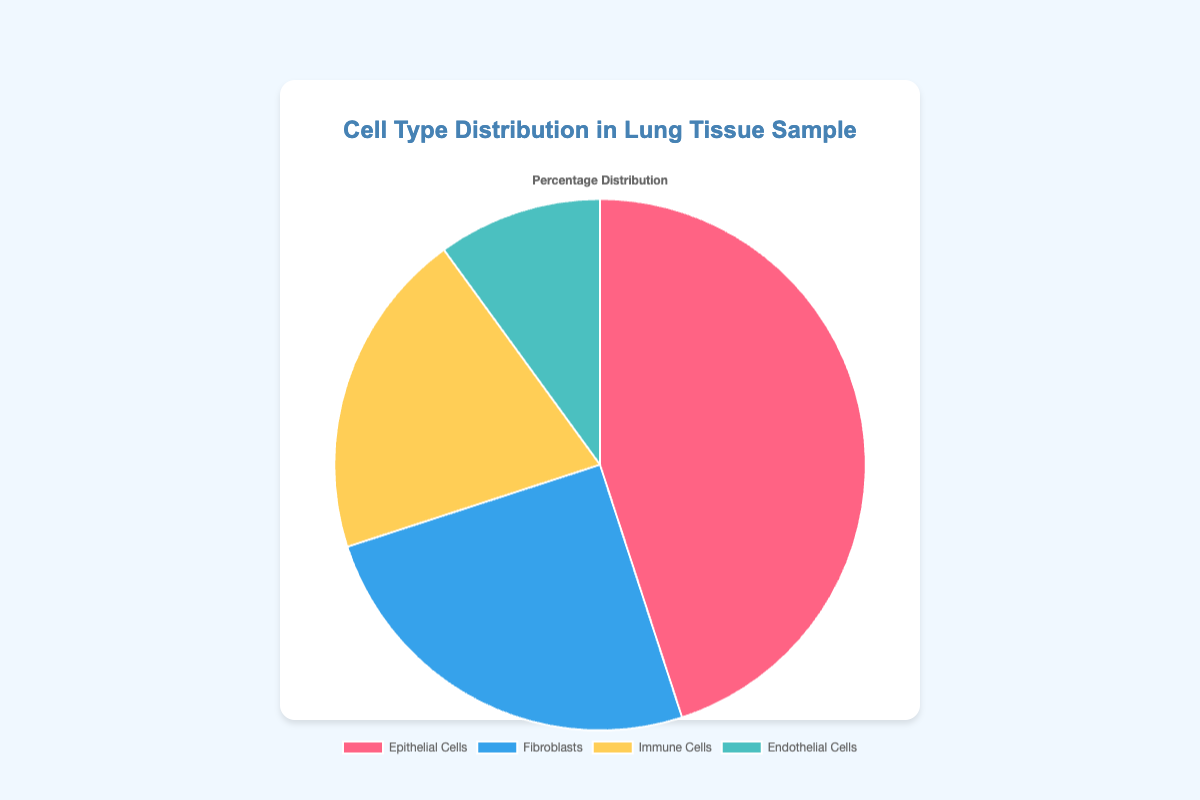What's the most abundant cell type in the lung tissue sample? The largest section of the pie chart represents the cell type with the highest percentage. Here, the section for Epithelial Cells is the largest.
Answer: Epithelial Cells What's the least abundant cell type in the lung tissue sample? The smallest section of the pie chart represents the cell type with the lowest percentage. Here, the section for Endothelial Cells is the smallest.
Answer: Endothelial Cells What is the combined percentage of Immune Cells and Fibroblasts? To find the combined percentage, add the percentages of Immune Cells (20%) and Fibroblasts (25%). 20 + 25 = 45
Answer: 45% How much larger is the percentage of Epithelial Cells compared to Endothelial Cells? Subtract the percentage of Endothelial Cells (10%) from the percentage of Epithelial Cells (45%). 45 - 10 = 35
Answer: 35% What percentage of the lung tissue sample is made up of cells that are not Immune Cells? Subtract the percentage of Immune Cells (20%) from the total (100%). 100 - 20 = 80
Answer: 80% Which cell type has a percentage that is closest to 25%? Compare the percentages of all cell types. The percentage closest to 25% is for Fibroblasts, which is exactly 25%.
Answer: Fibroblasts Are Epithelial Cells more than twice as abundant as Endothelial Cells? Compare twice the percentage of Endothelial Cells (2 * 10% = 20%) to the percentage of Epithelial Cells (45%). Since 45% is more than 20%, Epithelial Cells are more than twice as abundant as Endothelial Cells.
Answer: Yes If you were to merge Fibroblasts and Endothelial Cells into one group, what would the new group's percentage be? Add the percentages of Fibroblasts (25%) and Endothelial Cells (10%). 25 + 10 = 35
Answer: 35% Which two cell types together make up exactly 55% of the lung tissue sample? By adding different combinations of percentages, we find that Epithelial Cells (45%) + Endothelial Cells (10%) = 55%.
Answer: Epithelial Cells and Endothelial Cells How many cell types have a percentage greater than 20%? Identify the cell types with percentages greater than 20%. Epithelial Cells (45%) and Fibroblasts (25%) both meet this criterion.
Answer: 2 